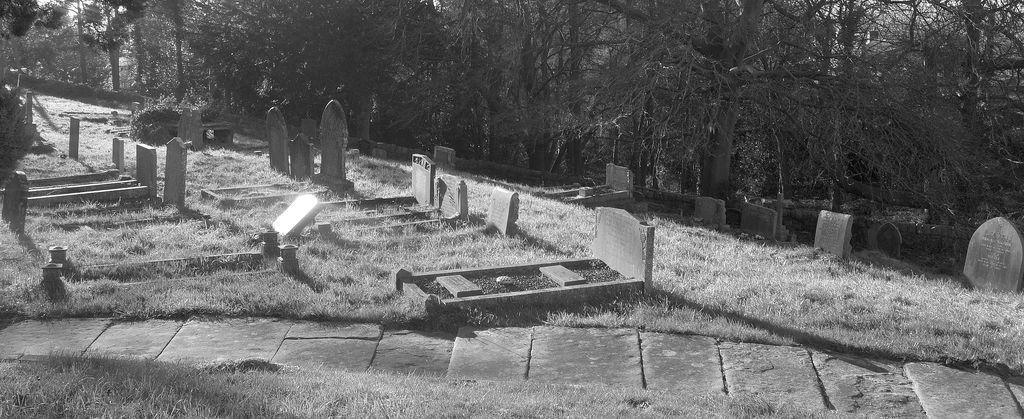What can be seen in the foreground of the image? There are graves and grassland in the foreground of the image. What type of vegetation is present in the foreground? There is grassland in the foreground of the image. What can be seen in the background of the image? There are trees and the sky visible in the background of the image. How many kittens are playing in the grassland in the image? There are no kittens present in the image; it features graves and grassland. In which direction is the north located in the image? The image does not provide any information about the direction of north. 